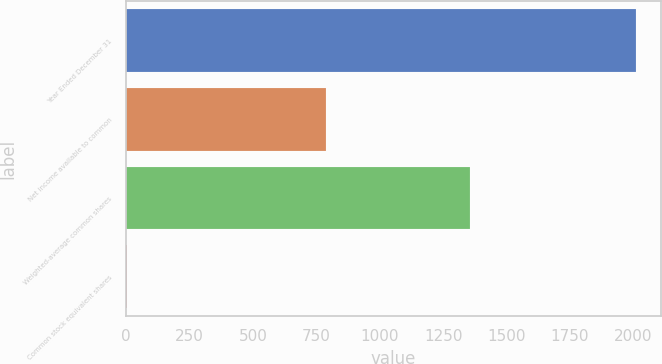<chart> <loc_0><loc_0><loc_500><loc_500><bar_chart><fcel>Year Ended December 31<fcel>Net income available to common<fcel>Weighted-average common shares<fcel>Common stock equivalent shares<nl><fcel>2009<fcel>787<fcel>1356.5<fcel>4<nl></chart> 